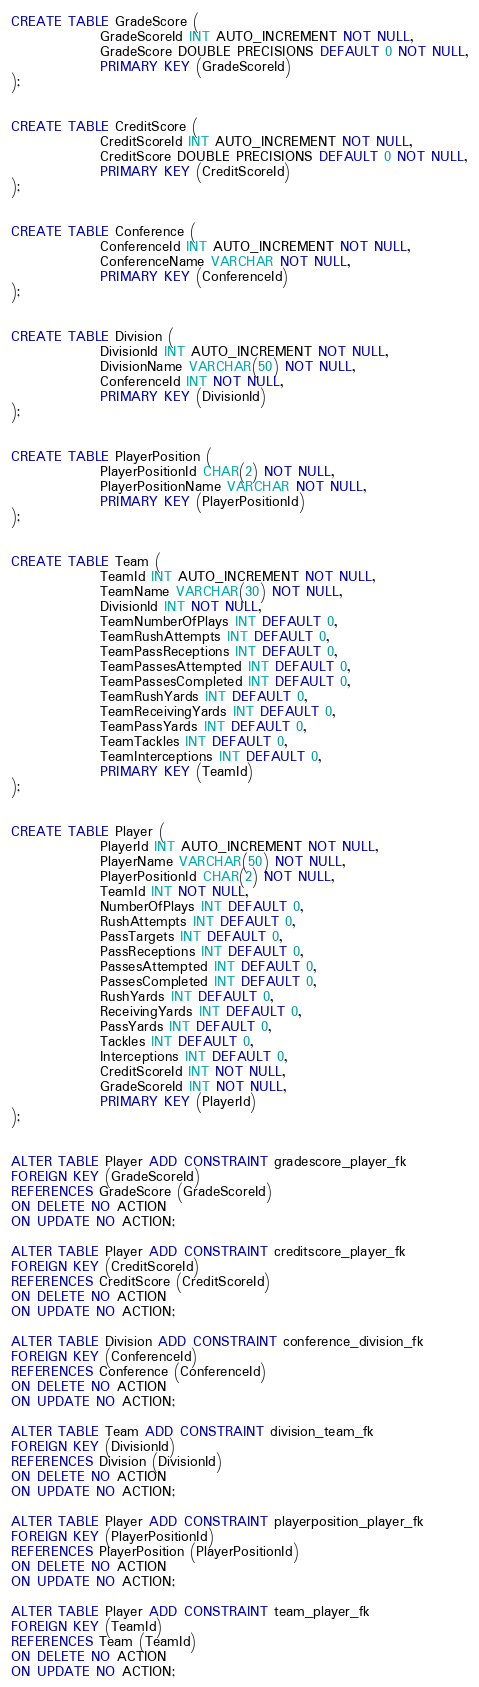<code> <loc_0><loc_0><loc_500><loc_500><_SQL_>
CREATE TABLE GradeScore (
                GradeScoreId INT AUTO_INCREMENT NOT NULL,
                GradeScore DOUBLE PRECISIONS DEFAULT 0 NOT NULL,
                PRIMARY KEY (GradeScoreId)
);


CREATE TABLE CreditScore (
                CreditScoreId INT AUTO_INCREMENT NOT NULL,
                CreditScore DOUBLE PRECISIONS DEFAULT 0 NOT NULL,
                PRIMARY KEY (CreditScoreId)
);


CREATE TABLE Conference (
                ConferenceId INT AUTO_INCREMENT NOT NULL,
                ConferenceName VARCHAR NOT NULL,
                PRIMARY KEY (ConferenceId)
);


CREATE TABLE Division (
                DivisionId INT AUTO_INCREMENT NOT NULL,
                DivisionName VARCHAR(50) NOT NULL,
                ConferenceId INT NOT NULL,
                PRIMARY KEY (DivisionId)
);


CREATE TABLE PlayerPosition (
                PlayerPositionId CHAR(2) NOT NULL,
                PlayerPositionName VARCHAR NOT NULL,
                PRIMARY KEY (PlayerPositionId)
);


CREATE TABLE Team (
                TeamId INT AUTO_INCREMENT NOT NULL,
                TeamName VARCHAR(30) NOT NULL,
                DivisionId INT NOT NULL,
                TeamNumberOfPlays INT DEFAULT 0,
                TeamRushAttempts INT DEFAULT 0,
                TeamPassReceptions INT DEFAULT 0,
                TeamPassesAttempted INT DEFAULT 0,
                TeamPassesCompleted INT DEFAULT 0,
                TeamRushYards INT DEFAULT 0,
                TeamReceivingYards INT DEFAULT 0,
                TeamPassYards INT DEFAULT 0,
                TeamTackles INT DEFAULT 0,
                TeamInterceptions INT DEFAULT 0,
                PRIMARY KEY (TeamId)
);


CREATE TABLE Player (
                PlayerId INT AUTO_INCREMENT NOT NULL,
                PlayerName VARCHAR(50) NOT NULL,
                PlayerPositionId CHAR(2) NOT NULL,
                TeamId INT NOT NULL,
                NumberOfPlays INT DEFAULT 0,
                RushAttempts INT DEFAULT 0,
                PassTargets INT DEFAULT 0,
                PassReceptions INT DEFAULT 0,
                PassesAttempted INT DEFAULT 0,
                PassesCompleted INT DEFAULT 0,
                RushYards INT DEFAULT 0,
                ReceivingYards INT DEFAULT 0,
                PassYards INT DEFAULT 0,
                Tackles INT DEFAULT 0,
                Interceptions INT DEFAULT 0,
                CreditScoreId INT NOT NULL,
                GradeScoreId INT NOT NULL,
                PRIMARY KEY (PlayerId)
);


ALTER TABLE Player ADD CONSTRAINT gradescore_player_fk
FOREIGN KEY (GradeScoreId)
REFERENCES GradeScore (GradeScoreId)
ON DELETE NO ACTION
ON UPDATE NO ACTION;

ALTER TABLE Player ADD CONSTRAINT creditscore_player_fk
FOREIGN KEY (CreditScoreId)
REFERENCES CreditScore (CreditScoreId)
ON DELETE NO ACTION
ON UPDATE NO ACTION;

ALTER TABLE Division ADD CONSTRAINT conference_division_fk
FOREIGN KEY (ConferenceId)
REFERENCES Conference (ConferenceId)
ON DELETE NO ACTION
ON UPDATE NO ACTION;

ALTER TABLE Team ADD CONSTRAINT division_team_fk
FOREIGN KEY (DivisionId)
REFERENCES Division (DivisionId)
ON DELETE NO ACTION
ON UPDATE NO ACTION;

ALTER TABLE Player ADD CONSTRAINT playerposition_player_fk
FOREIGN KEY (PlayerPositionId)
REFERENCES PlayerPosition (PlayerPositionId)
ON DELETE NO ACTION
ON UPDATE NO ACTION;

ALTER TABLE Player ADD CONSTRAINT team_player_fk
FOREIGN KEY (TeamId)
REFERENCES Team (TeamId)
ON DELETE NO ACTION
ON UPDATE NO ACTION;
</code> 